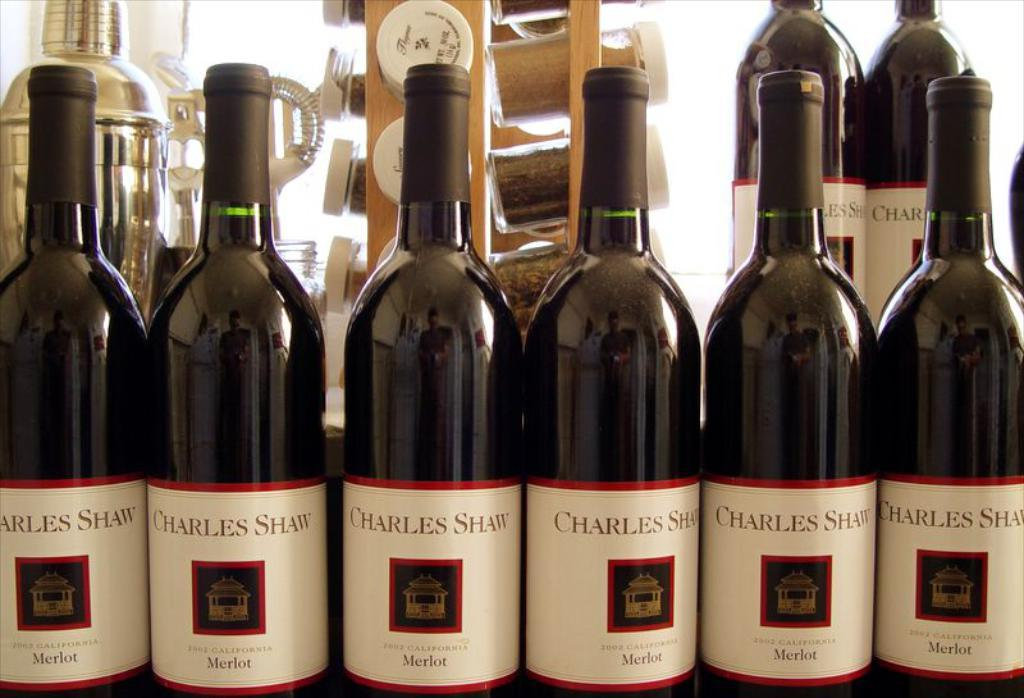<image>
Give a short and clear explanation of the subsequent image. A row of wine bottles display the brand Charles Shaw. 